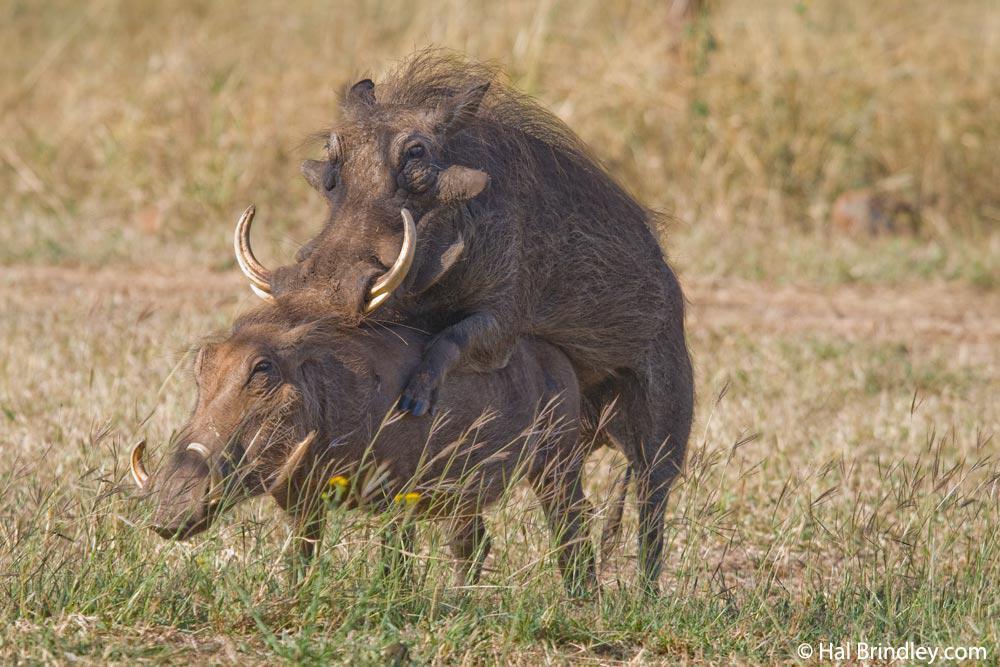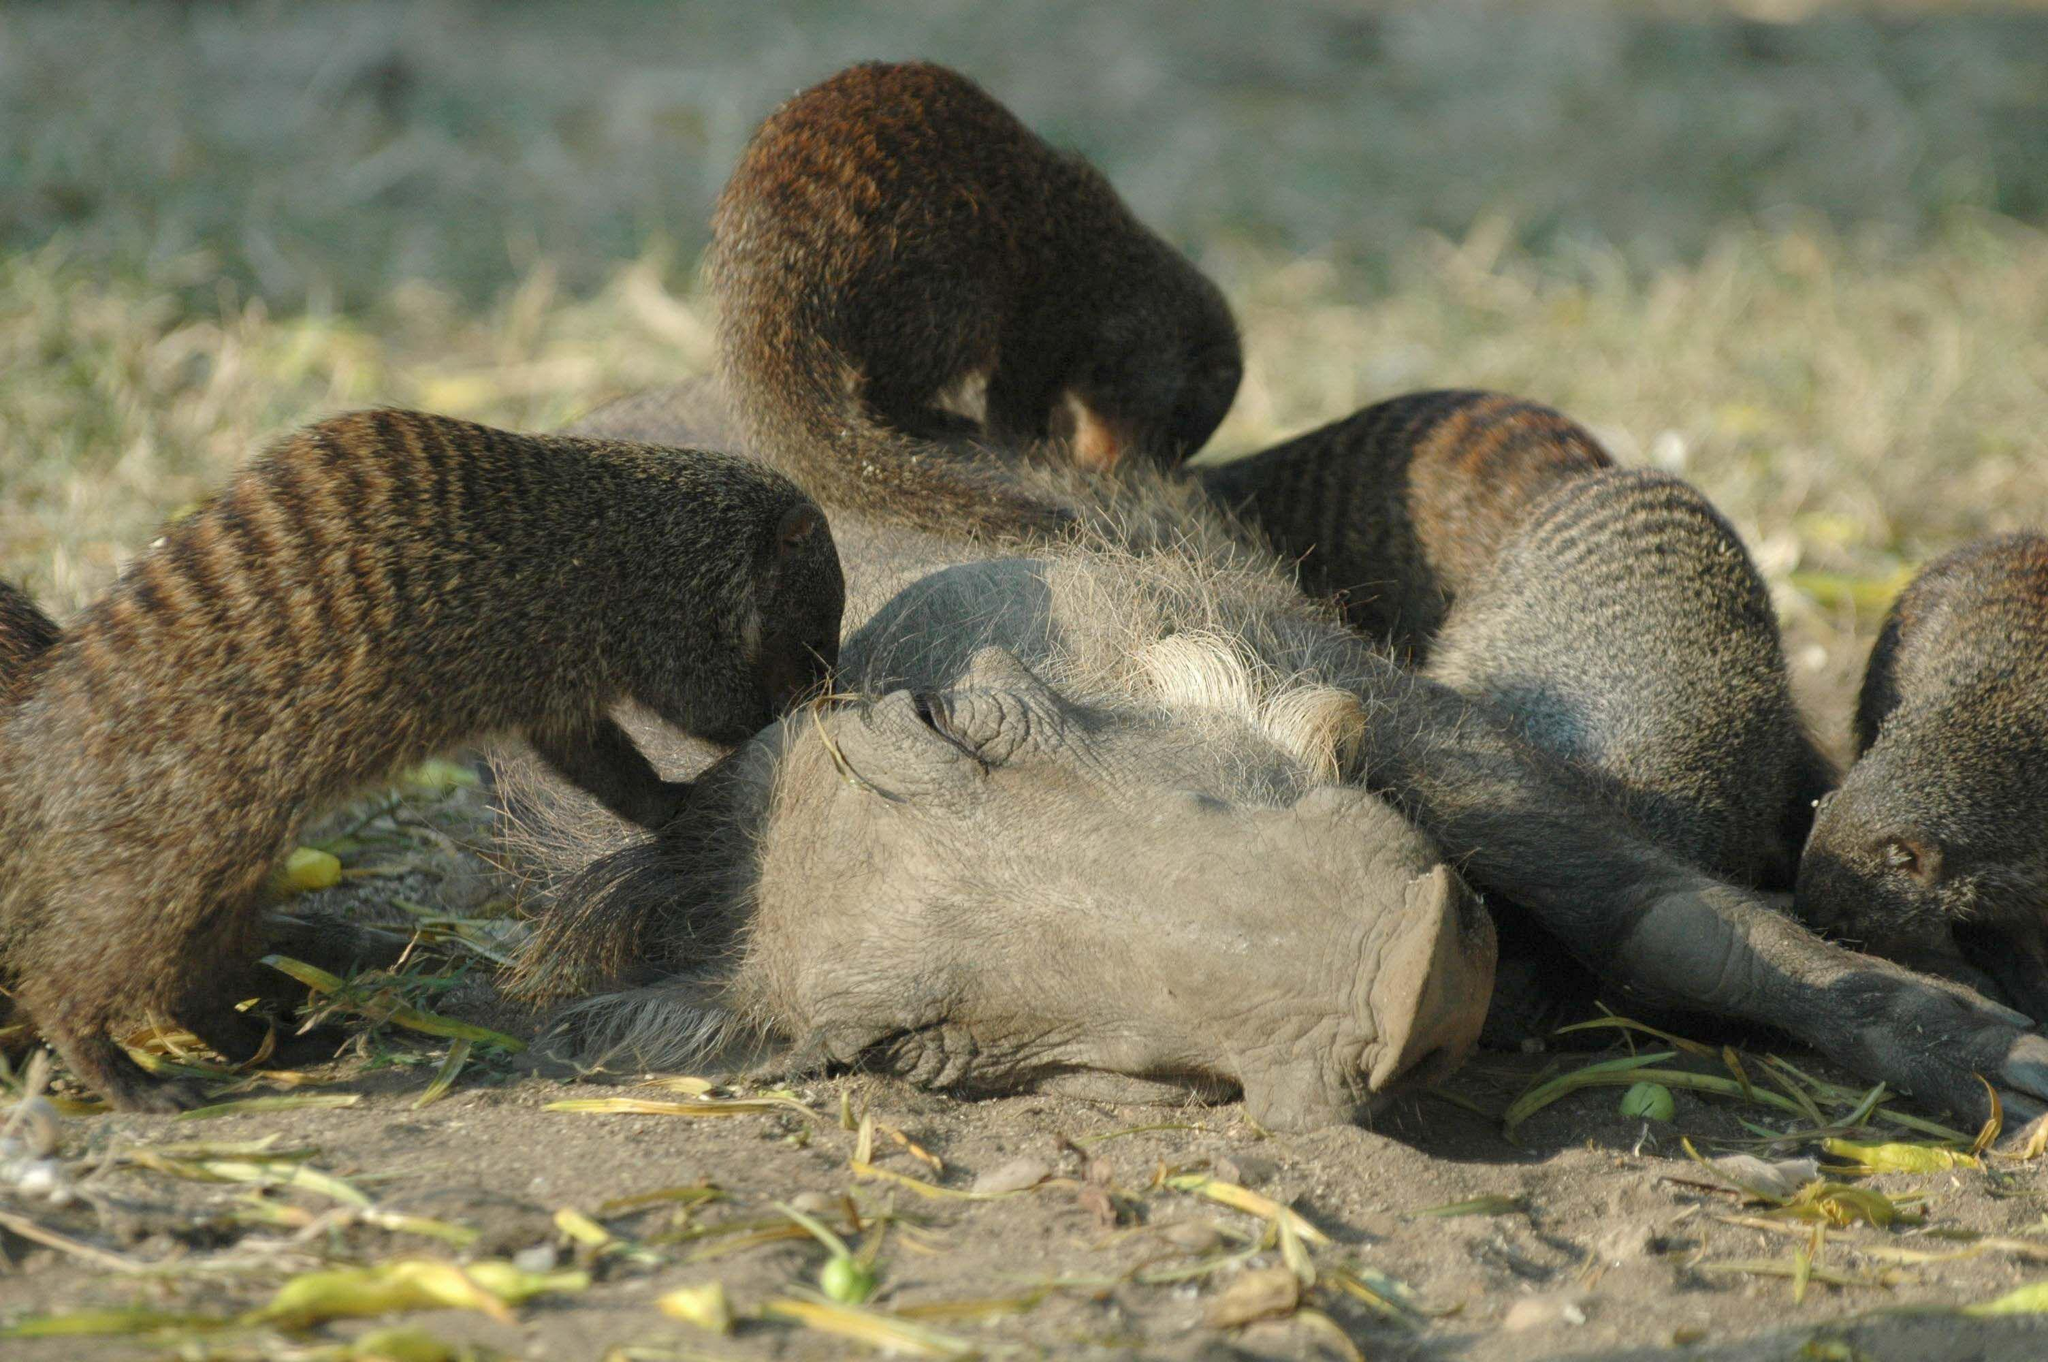The first image is the image on the left, the second image is the image on the right. Evaluate the accuracy of this statement regarding the images: "At least one warthog is near water.". Is it true? Answer yes or no. No. The first image is the image on the left, the second image is the image on the right. Assess this claim about the two images: "The image on the left contains no more than two wart hogs.". Correct or not? Answer yes or no. Yes. 